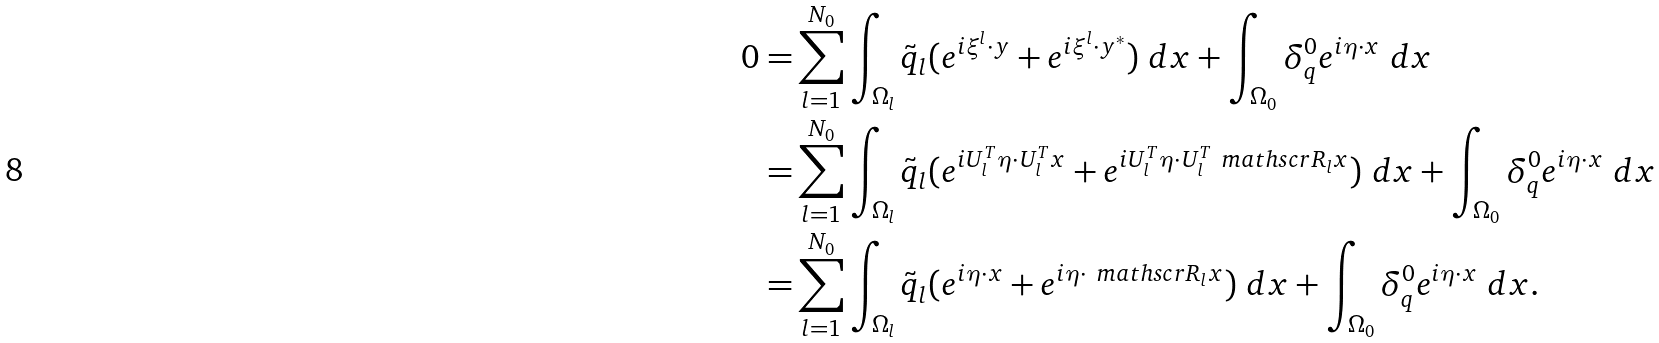Convert formula to latex. <formula><loc_0><loc_0><loc_500><loc_500>0 = & \sum _ { l = 1 } ^ { N _ { 0 } } \int _ { \Omega _ { l } } \tilde { q } _ { l } ( e ^ { i \xi ^ { l } \cdot y } + e ^ { i \xi ^ { l } \cdot y ^ { * } } ) \ d x + \int _ { \Omega _ { 0 } } \delta _ { q } ^ { 0 } e ^ { i \eta \cdot x } \ d x \\ = & \sum _ { l = 1 } ^ { N _ { 0 } } \int _ { \Omega _ { l } } \tilde { q } _ { l } ( e ^ { i U _ { l } ^ { T } \eta \cdot U _ { l } ^ { T } x } + e ^ { i U _ { l } ^ { T } \eta \cdot U _ { l } ^ { T } \ m a t h s c r { R } _ { l } x } ) \ d x + \int _ { \Omega _ { 0 } } \delta _ { q } ^ { 0 } e ^ { i \eta \cdot x } \ d x \\ = & \sum _ { l = 1 } ^ { N _ { 0 } } \int _ { \Omega _ { l } } \tilde { q } _ { l } ( e ^ { i \eta \cdot x } + e ^ { i \eta \cdot \ m a t h s c r { R } _ { l } x } ) \ d x + \int _ { \Omega _ { 0 } } \delta _ { q } ^ { 0 } e ^ { i \eta \cdot x } \ d x .</formula> 